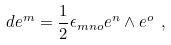<formula> <loc_0><loc_0><loc_500><loc_500>d e ^ { m } = \frac { 1 } { 2 } \epsilon _ { m n o } e ^ { n } \wedge e ^ { o } \ ,</formula> 